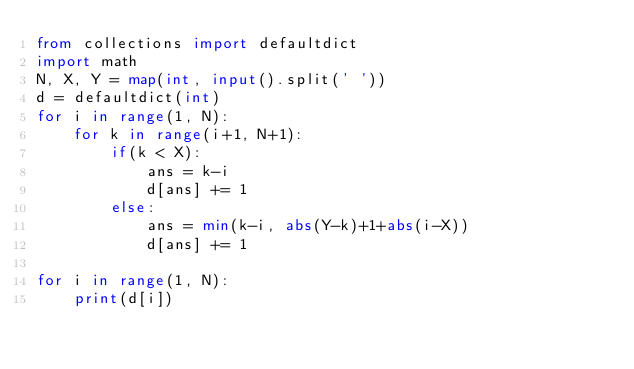Convert code to text. <code><loc_0><loc_0><loc_500><loc_500><_Python_>from collections import defaultdict
import math
N, X, Y = map(int, input().split(' '))
d = defaultdict(int)
for i in range(1, N):
    for k in range(i+1, N+1):
        if(k < X):
            ans = k-i
            d[ans] += 1
        else:
            ans = min(k-i, abs(Y-k)+1+abs(i-X))
            d[ans] += 1

for i in range(1, N):
    print(d[i])
</code> 